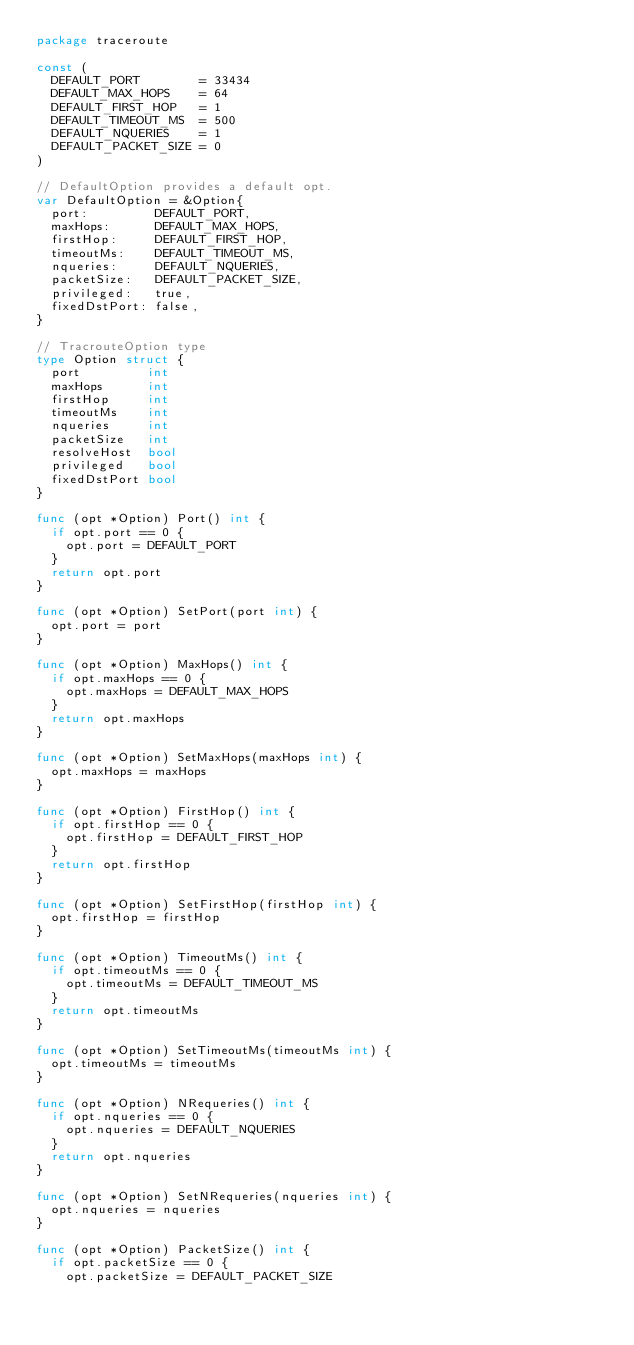<code> <loc_0><loc_0><loc_500><loc_500><_Go_>package traceroute

const (
	DEFAULT_PORT        = 33434
	DEFAULT_MAX_HOPS    = 64
	DEFAULT_FIRST_HOP   = 1
	DEFAULT_TIMEOUT_MS  = 500
	DEFAULT_NQUERIES    = 1
	DEFAULT_PACKET_SIZE = 0
)

// DefaultOption provides a default opt.
var DefaultOption = &Option{
	port:         DEFAULT_PORT,
	maxHops:      DEFAULT_MAX_HOPS,
	firstHop:     DEFAULT_FIRST_HOP,
	timeoutMs:    DEFAULT_TIMEOUT_MS,
	nqueries:     DEFAULT_NQUERIES,
	packetSize:   DEFAULT_PACKET_SIZE,
	privileged:   true,
	fixedDstPort: false,
}

// TracrouteOption type
type Option struct {
	port         int
	maxHops      int
	firstHop     int
	timeoutMs    int
	nqueries     int
	packetSize   int
	resolveHost  bool
	privileged   bool
	fixedDstPort bool
}

func (opt *Option) Port() int {
	if opt.port == 0 {
		opt.port = DEFAULT_PORT
	}
	return opt.port
}

func (opt *Option) SetPort(port int) {
	opt.port = port
}

func (opt *Option) MaxHops() int {
	if opt.maxHops == 0 {
		opt.maxHops = DEFAULT_MAX_HOPS
	}
	return opt.maxHops
}

func (opt *Option) SetMaxHops(maxHops int) {
	opt.maxHops = maxHops
}

func (opt *Option) FirstHop() int {
	if opt.firstHop == 0 {
		opt.firstHop = DEFAULT_FIRST_HOP
	}
	return opt.firstHop
}

func (opt *Option) SetFirstHop(firstHop int) {
	opt.firstHop = firstHop
}

func (opt *Option) TimeoutMs() int {
	if opt.timeoutMs == 0 {
		opt.timeoutMs = DEFAULT_TIMEOUT_MS
	}
	return opt.timeoutMs
}

func (opt *Option) SetTimeoutMs(timeoutMs int) {
	opt.timeoutMs = timeoutMs
}

func (opt *Option) NRequeries() int {
	if opt.nqueries == 0 {
		opt.nqueries = DEFAULT_NQUERIES
	}
	return opt.nqueries
}

func (opt *Option) SetNRequeries(nqueries int) {
	opt.nqueries = nqueries
}

func (opt *Option) PacketSize() int {
	if opt.packetSize == 0 {
		opt.packetSize = DEFAULT_PACKET_SIZE</code> 